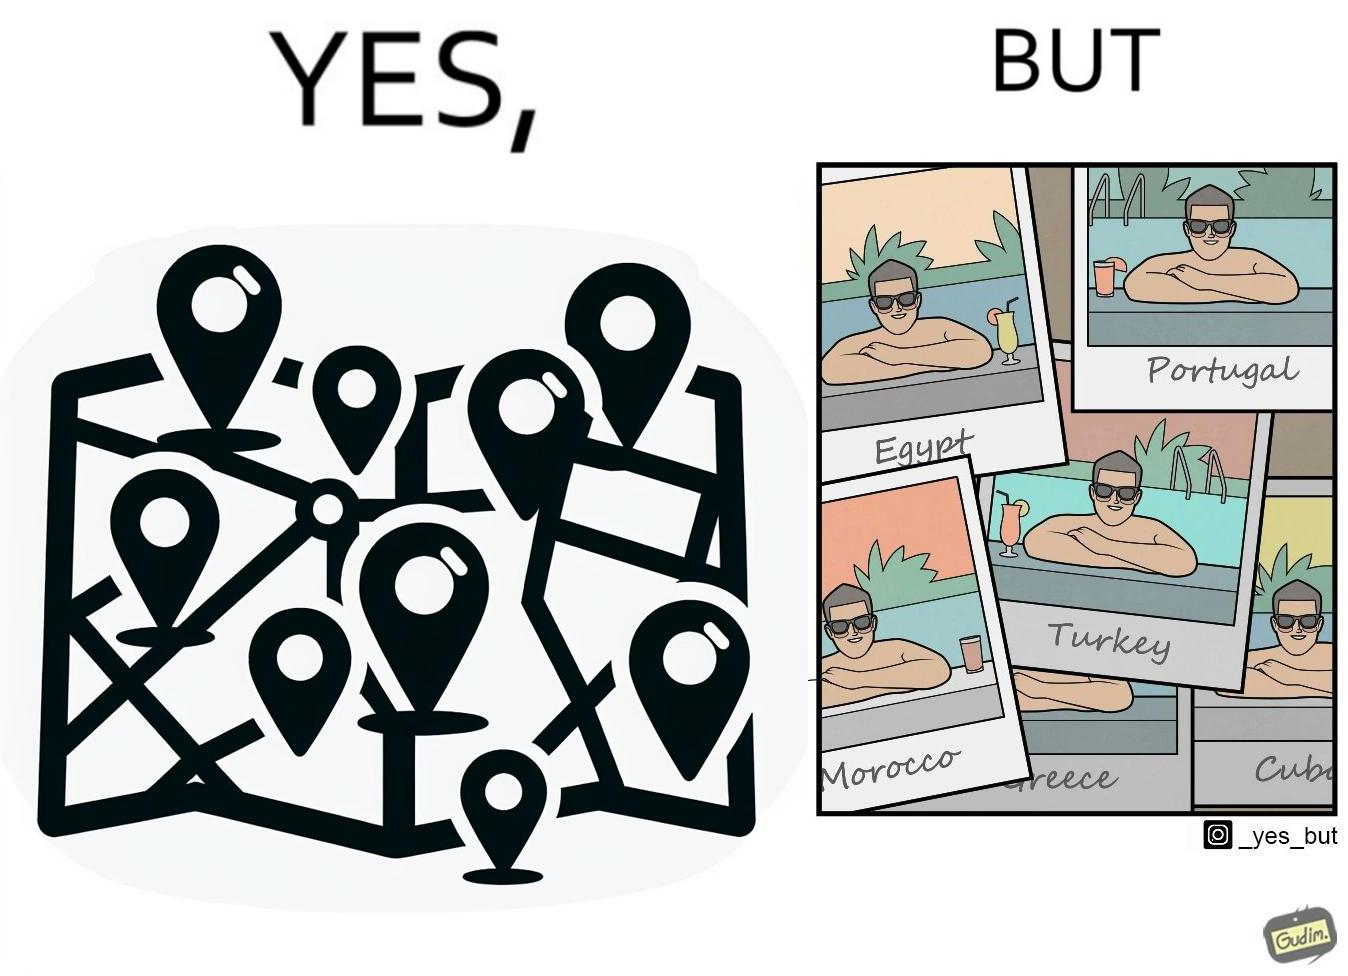What is shown in this image? The image is satirical because while the man has visited all the place marked on the map, he only seems to have swam in pools in all these differnt countries and has not actually seen these places. 